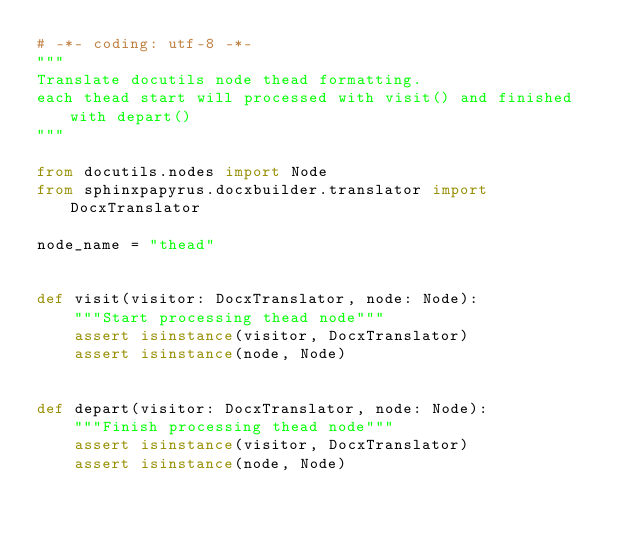Convert code to text. <code><loc_0><loc_0><loc_500><loc_500><_Python_># -*- coding: utf-8 -*-
"""
Translate docutils node thead formatting.
each thead start will processed with visit() and finished with depart()
"""

from docutils.nodes import Node
from sphinxpapyrus.docxbuilder.translator import DocxTranslator

node_name = "thead"


def visit(visitor: DocxTranslator, node: Node):
    """Start processing thead node"""
    assert isinstance(visitor, DocxTranslator)
    assert isinstance(node, Node)


def depart(visitor: DocxTranslator, node: Node):
    """Finish processing thead node"""
    assert isinstance(visitor, DocxTranslator)
    assert isinstance(node, Node)
</code> 